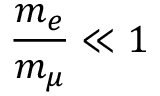<formula> <loc_0><loc_0><loc_500><loc_500>\frac { m _ { e } } { m _ { \mu } } \ll 1</formula> 